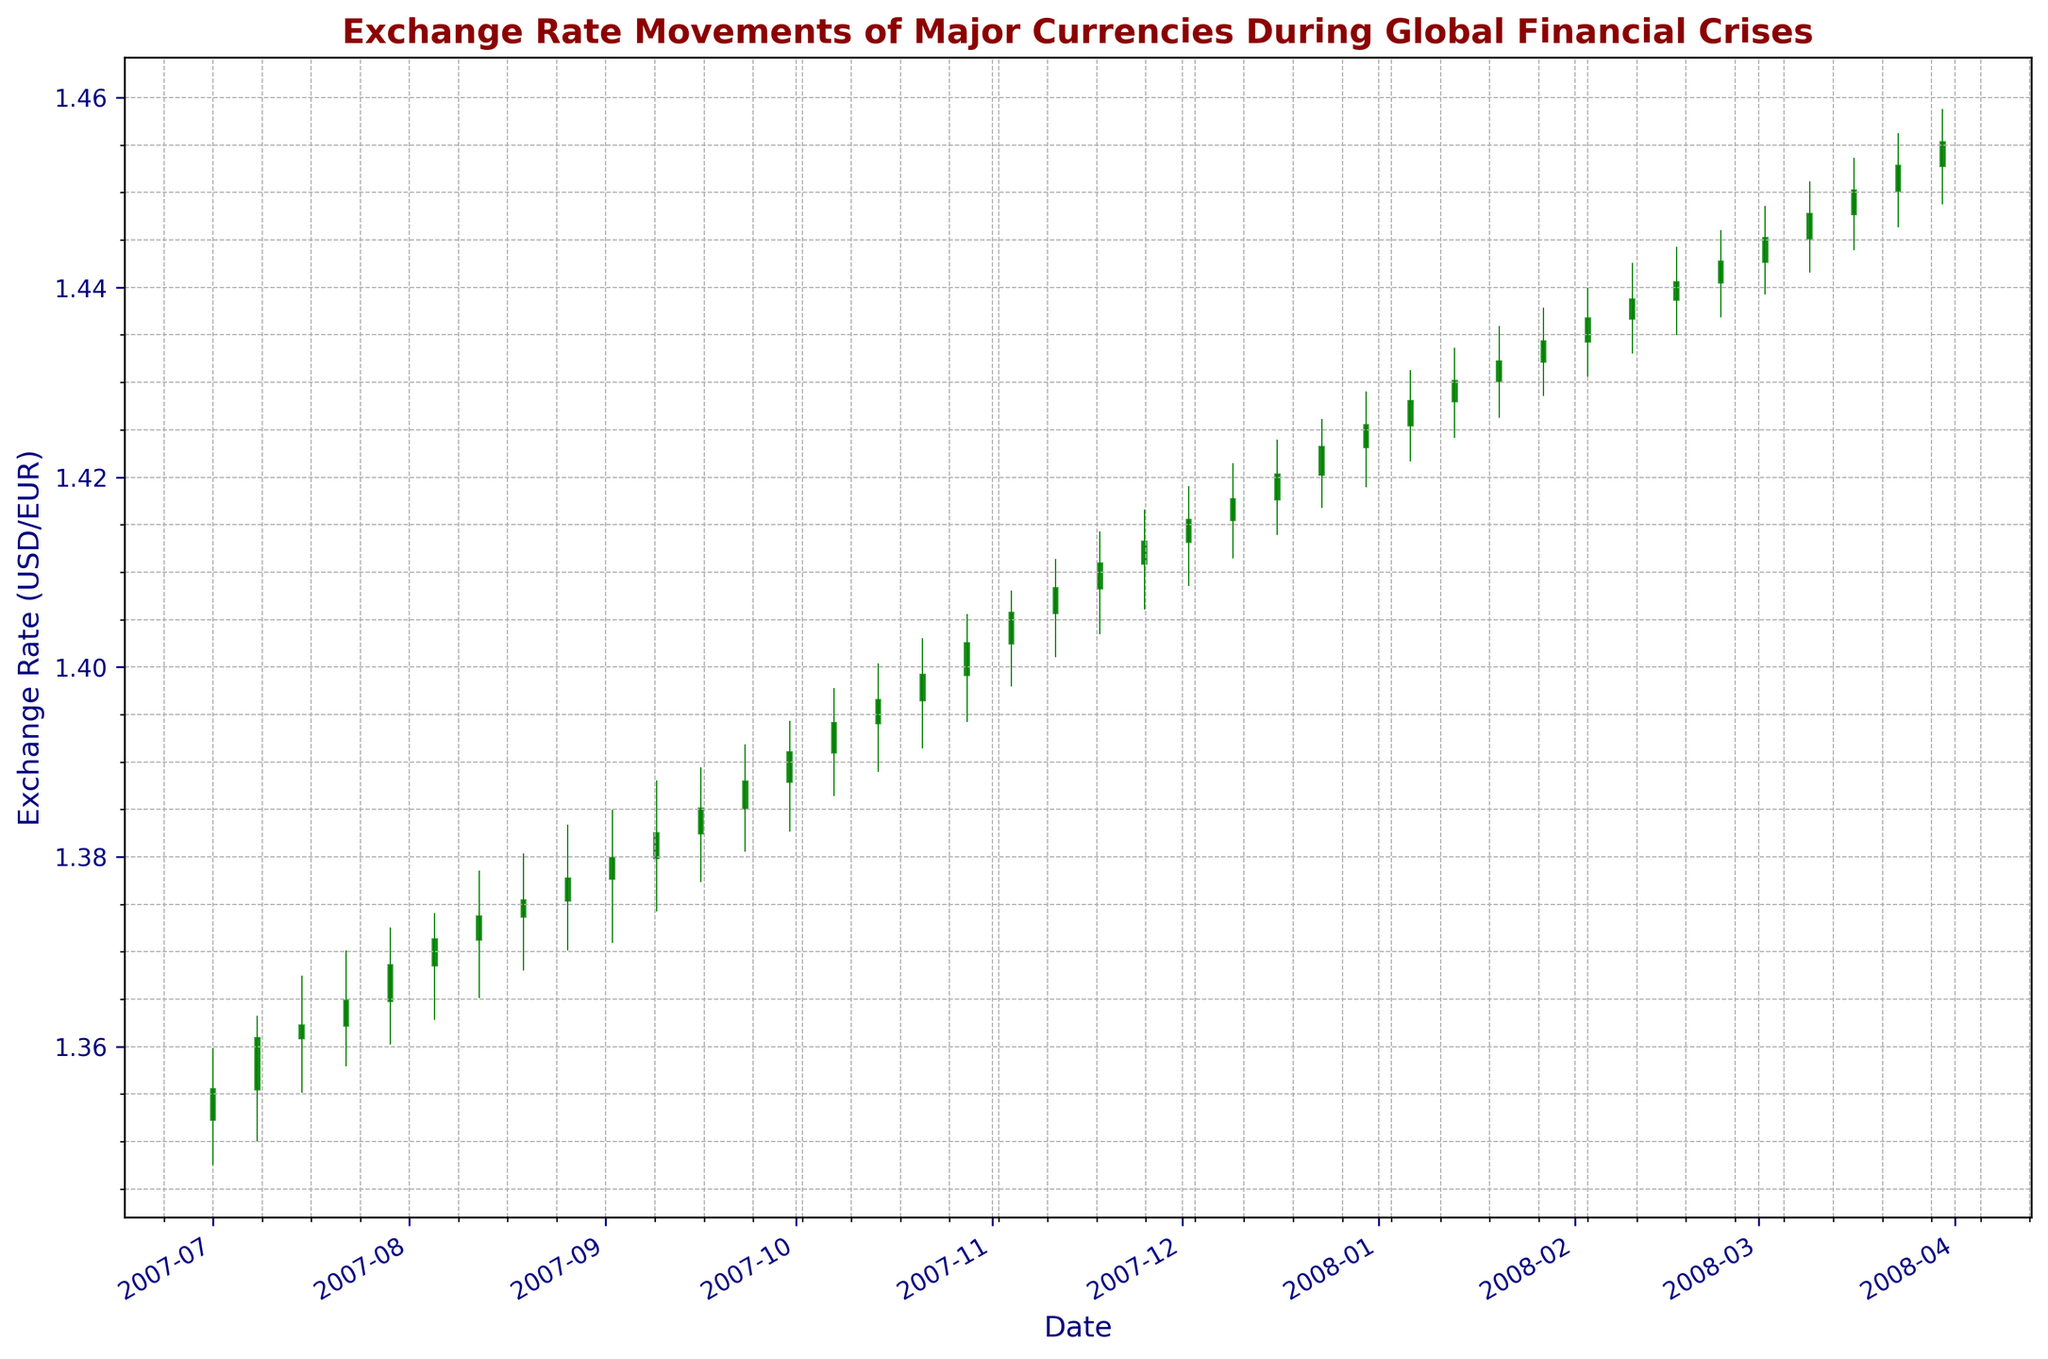What is the overall trend of the exchange rate from July 2007 to March 2008? By observing the candlestick chart, we can see that the general movement of the exchange rate (USD/EUR) shows a steady increase from the start in July 2007 to the end in March 2008. This indicates an overall uptrend.
Answer: Uptrend Which week in the dataset experienced the highest high point for the exchange rate? To find the highest high point, visually scan the chart for the tallest upper shadow or candle. The highest point is reached in the week of December 30, 2007, where the high point is at 1.4290 (the upper shadow of the candlestick).
Answer: December 30, 2007 During which period do we see the highest trading volume? The trading volume can be assessed by the height of the volume bars below the candlestick chart. The highest volume bar appears towards the end of the dataset, particularly for the week of March 30, 2008.
Answer: March 30, 2008 Between which two consecutive weeks is the largest change in the closing price observed? To determine the largest change in the closing price between two consecutive weeks, compare the differences in their closing values. The biggest change occurs between the weeks of December 30, 2007, and January 6, 2008. The closing price increased from 1.4255 to 1.4280.
Answer: December 30, 2007 and January 6, 2008 How many green candlesticks are there in the chart? Green candlesticks indicate weeks where the closing price was higher than the opening price, usually marked in green. By counting these, we see there are 27 green candlesticks in total.
Answer: 27 Which month shows the most significant increase in the exchange rate? To determine the month with the most significant increase, examine the closing prices from the beginning to the end of each month and find the difference. March 2008 shows the most significant increase, starting from around 1.4452 and ending at 1.4553.
Answer: March 2008 What was the closing price on October 28, 2007, and how does it compare to the closing price on September 2, 2007? We locate these two dates on the x-axis and check their corresponding closing prices. The closing price on October 28, 2007 was 1.4025, and on September 2, 2007, it was 1.3799. The difference is 1.4025 - 1.3799 = 0.0226, with the October closing price being higher.
Answer: October 28, 2007 closing price is 1.4025, which is 0.0226 higher What are the average opening and closing prices for December 2007? Calculate the average by summing all the opening and closing prices for December 2007 and then dividing by the number of weeks (5). Opening prices: (1.4132 + 1.4155 + 1.4177 + 1.4203 + 1.4232) = 7.0899, Average opening = 7.0899/5 = 1.41798. Closing prices: (1.4155 + 1.4177 + 1.4203 + 1.4232 + 1.4255) = 7.1022, Average closing = 7.1022/5 = 1.42044.
Answer: Opening: 1.41798, Closing: 1.42044 